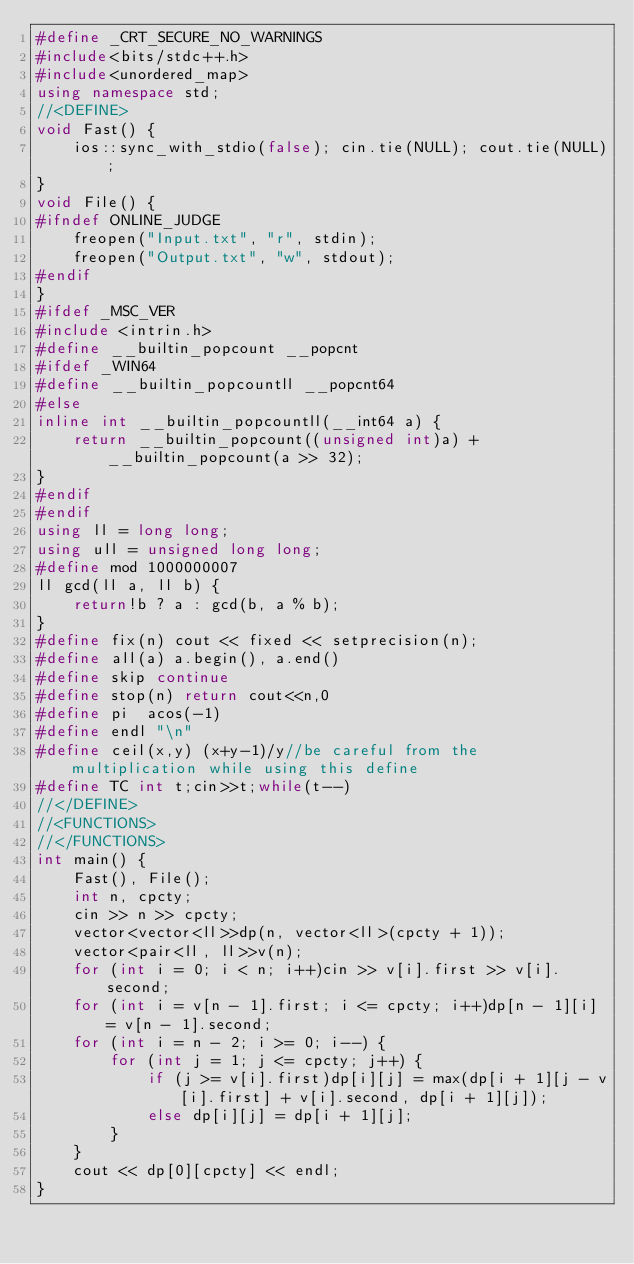Convert code to text. <code><loc_0><loc_0><loc_500><loc_500><_C++_>#define _CRT_SECURE_NO_WARNINGS
#include<bits/stdc++.h>
#include<unordered_map>
using namespace std;
//<DEFINE>
void Fast() {
	ios::sync_with_stdio(false); cin.tie(NULL); cout.tie(NULL);
}
void File() {
#ifndef ONLINE_JUDGE
	freopen("Input.txt", "r", stdin);
	freopen("Output.txt", "w", stdout);
#endif
}
#ifdef _MSC_VER
#include <intrin.h>
#define __builtin_popcount __popcnt
#ifdef _WIN64
#define __builtin_popcountll __popcnt64
#else
inline int __builtin_popcountll(__int64 a) {
	return __builtin_popcount((unsigned int)a) + __builtin_popcount(a >> 32);
}
#endif
#endif
using ll = long long;
using ull = unsigned long long;
#define mod 1000000007
ll gcd(ll a, ll b) {
	return!b ? a : gcd(b, a % b);
}
#define fix(n) cout << fixed << setprecision(n);
#define all(a) a.begin(), a.end()
#define skip continue
#define stop(n) return cout<<n,0
#define pi  acos(-1)
#define endl "\n"
#define ceil(x,y) (x+y-1)/y//be careful from the multiplication while using this define 
#define TC int t;cin>>t;while(t--)
//</DEFINE>
//<FUNCTIONS>
//</FUNCTIONS>	
int main() {
	Fast(), File();
	int n, cpcty;
	cin >> n >> cpcty;
	vector<vector<ll>>dp(n, vector<ll>(cpcty + 1));
	vector<pair<ll, ll>>v(n);
	for (int i = 0; i < n; i++)cin >> v[i].first >> v[i].second;
	for (int i = v[n - 1].first; i <= cpcty; i++)dp[n - 1][i] = v[n - 1].second;
	for (int i = n - 2; i >= 0; i--) {
		for (int j = 1; j <= cpcty; j++) {
			if (j >= v[i].first)dp[i][j] = max(dp[i + 1][j - v[i].first] + v[i].second, dp[i + 1][j]);
			else dp[i][j] = dp[i + 1][j];
		}
	}
	cout << dp[0][cpcty] << endl;
}</code> 